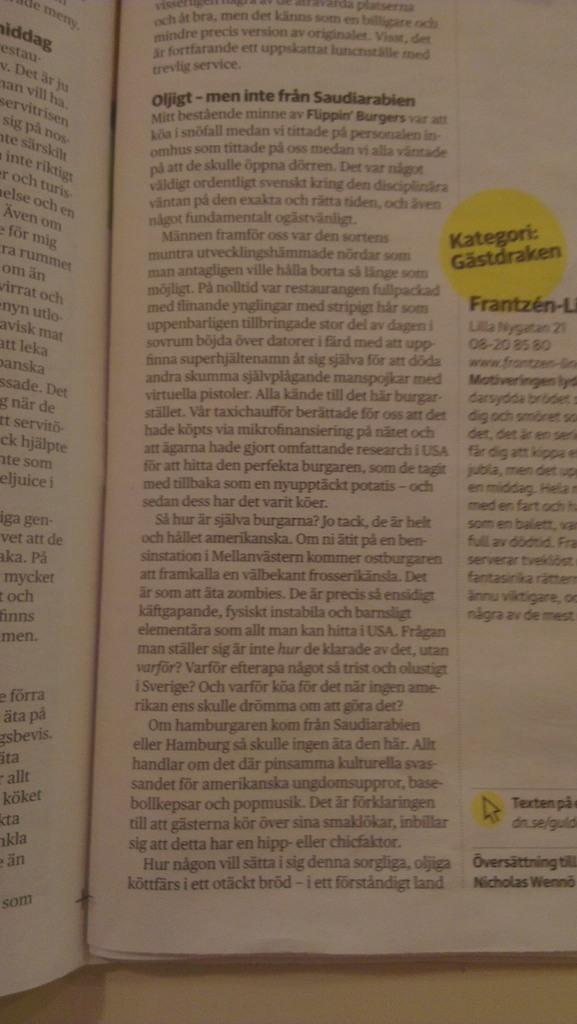<image>
Provide a brief description of the given image. Open book about Oljigt and Frantzen with Kategori Gastdraken highlighted in a circle. 